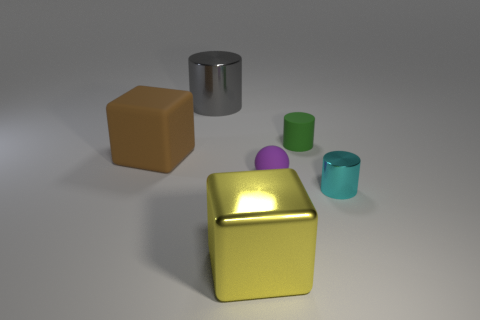How many cubes are in front of the tiny purple ball and to the left of the gray metallic cylinder?
Ensure brevity in your answer.  0. The cyan metallic object that is in front of the gray thing has what shape?
Provide a short and direct response. Cylinder. What number of other tiny cyan things have the same material as the cyan object?
Your response must be concise. 0. There is a gray metal object; is it the same shape as the tiny object that is behind the brown matte thing?
Your answer should be compact. Yes. There is a thing that is to the right of the tiny cylinder behind the big matte cube; are there any tiny green objects on the left side of it?
Give a very brief answer. Yes. There is a metallic cylinder that is right of the green matte cylinder; how big is it?
Ensure brevity in your answer.  Small. There is a green thing that is the same size as the purple rubber object; what is its material?
Give a very brief answer. Rubber. Is the big yellow thing the same shape as the small purple thing?
Provide a short and direct response. No. How many things are big shiny objects or cubes that are on the left side of the yellow shiny cube?
Offer a very short reply. 3. There is a matte thing behind the brown cube; is it the same size as the big yellow metallic cube?
Give a very brief answer. No. 